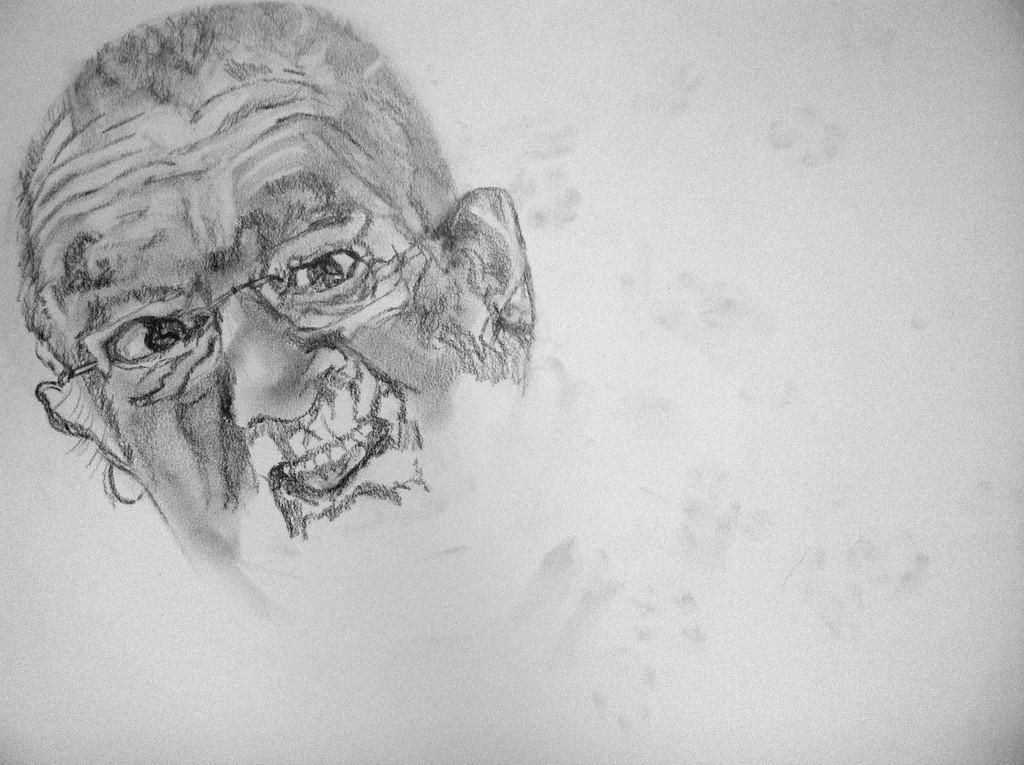Describe this image in one or two sentences. The picture is a drawing, towards left we can see the drawing of a person's face. 